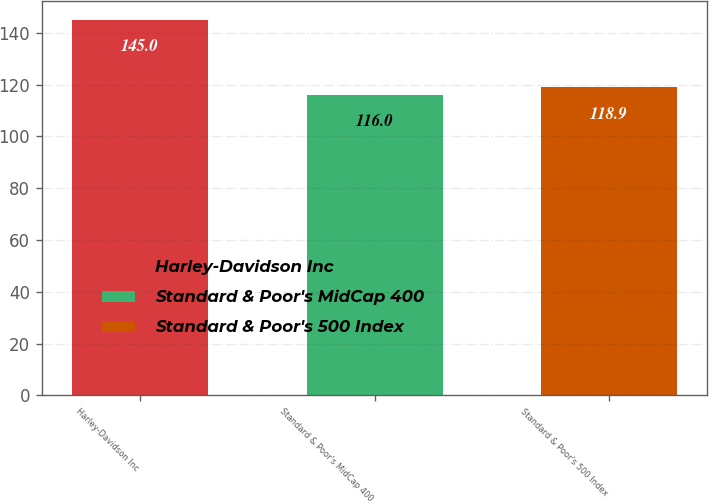Convert chart to OTSL. <chart><loc_0><loc_0><loc_500><loc_500><bar_chart><fcel>Harley-Davidson Inc<fcel>Standard & Poor's MidCap 400<fcel>Standard & Poor's 500 Index<nl><fcel>145<fcel>116<fcel>118.9<nl></chart> 